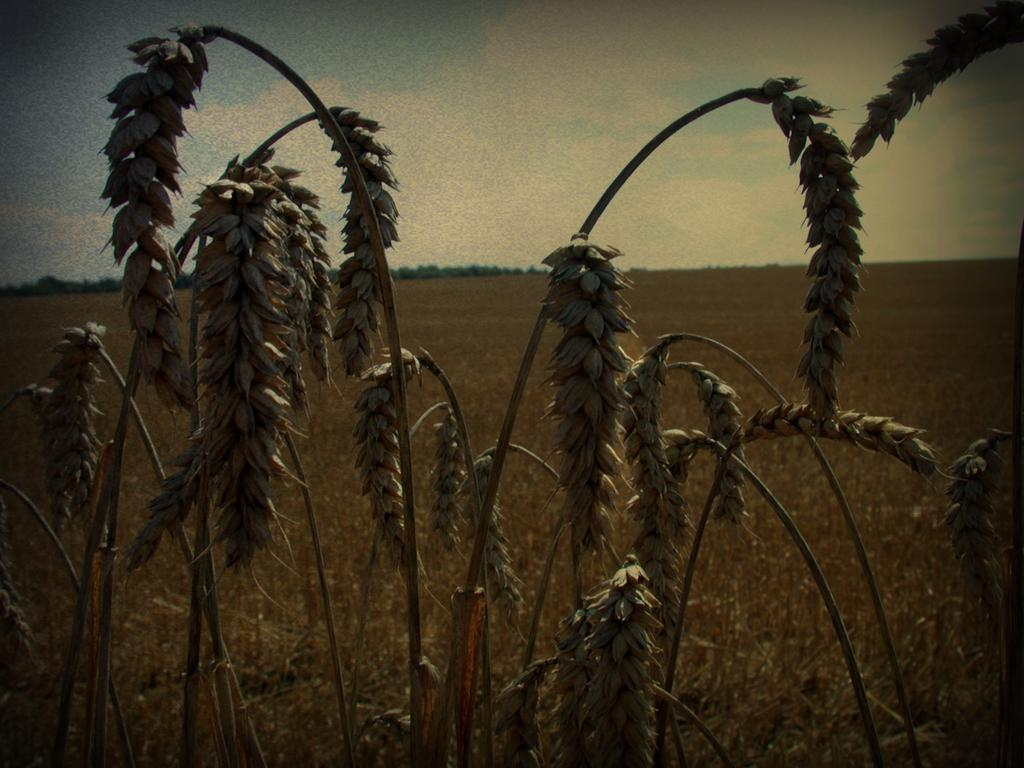What type of vegetation can be seen in the image? There are plants, grass, and trees in the image. What is the ground covered with in the image? The ground is covered with grass in the image. What can be seen in the sky in the image? The sky is blue and cloudy in the image. What type of authority figure is present in the image? There is no authority figure present in the image; it features plants, grass, trees, and a blue, cloudy sky. Can you see any wounds on the plants in the image? There are no wounds visible on the plants in the image; they appear healthy and undamaged. 